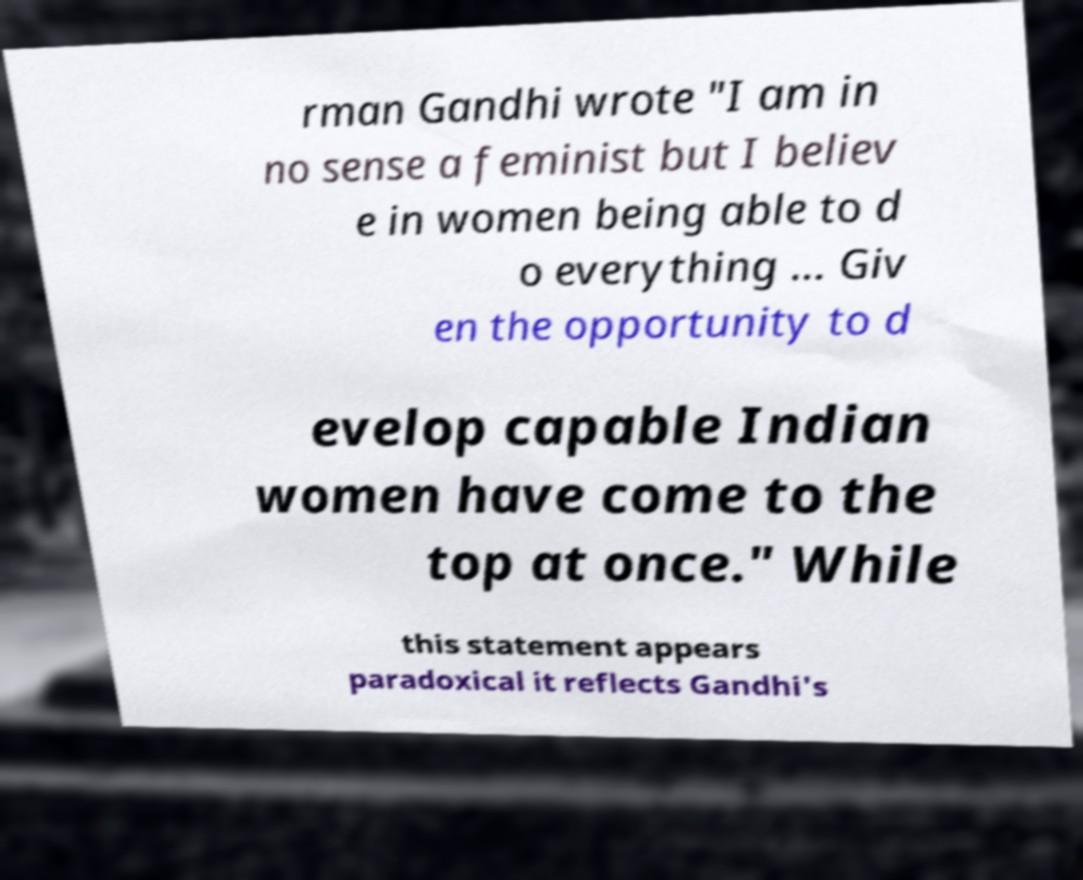For documentation purposes, I need the text within this image transcribed. Could you provide that? rman Gandhi wrote "I am in no sense a feminist but I believ e in women being able to d o everything ... Giv en the opportunity to d evelop capable Indian women have come to the top at once." While this statement appears paradoxical it reflects Gandhi's 